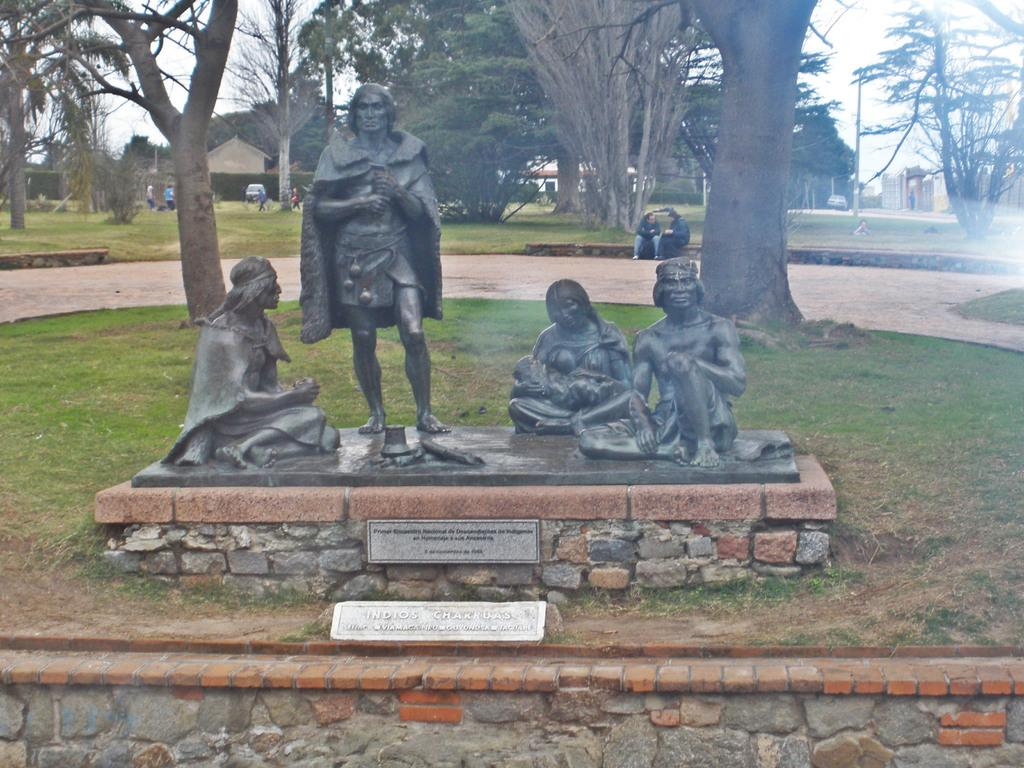What type of objects can be seen in the image? There are statues in the image. Are there any labels or identifiers associated with the statues? Yes, there are name plates in the image. What is the ground like in the image? The ground with grass is visible in the image. What type of vegetation is present in the image? There are trees in the image. What are the poles used for in the image? The purpose of the poles is not specified, but they are visible in the image. Can you describe the people in the image? There are people in the image, but their specific actions or characteristics are not mentioned in the facts. What type of structures can be seen in the image? There are buildings in the image. What is visible in the sky in the image? The sky is visible in the image. How many minutes does it take for the giants to walk from one statue to another in the image? There are no giants present in the image, so it is not possible to determine how long it would take for them to walk between statues. 